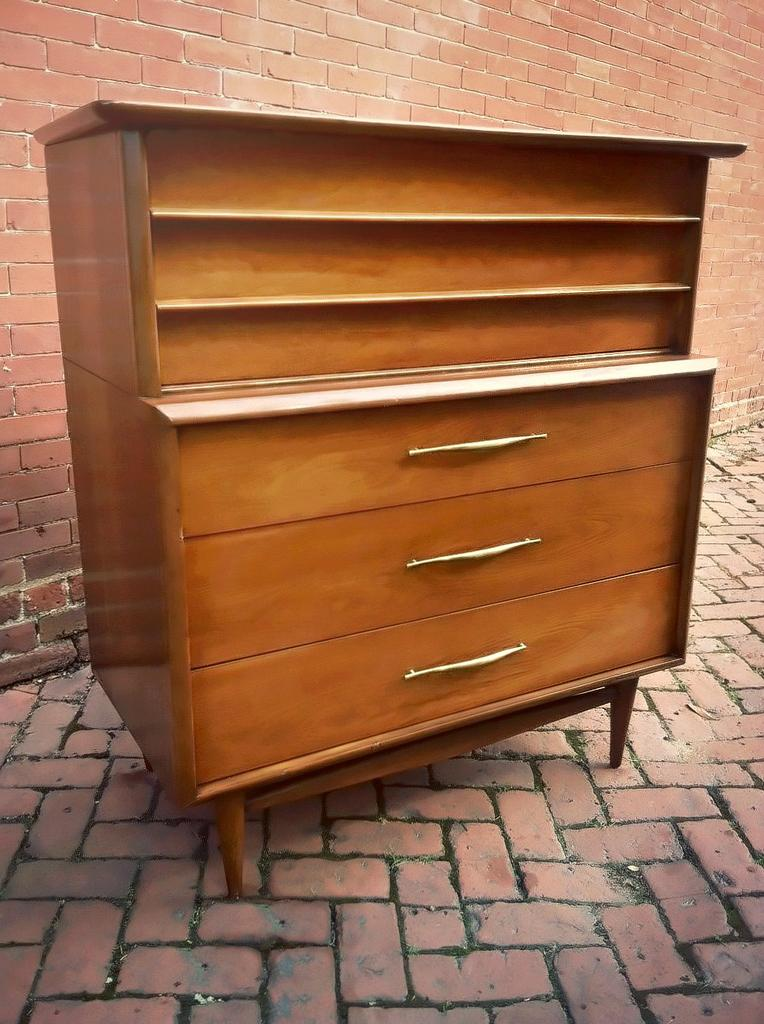What type of material is the wooden object made of in the image? The wooden object in the image is made of wood. What can be seen in the background of the image? There is a brick wall in the background of the image. How many dinosaurs can be seen interacting with the wooden object in the image? There are no dinosaurs present in the image. What type of muscle is visible in the image? There is no muscle visible in the image. 